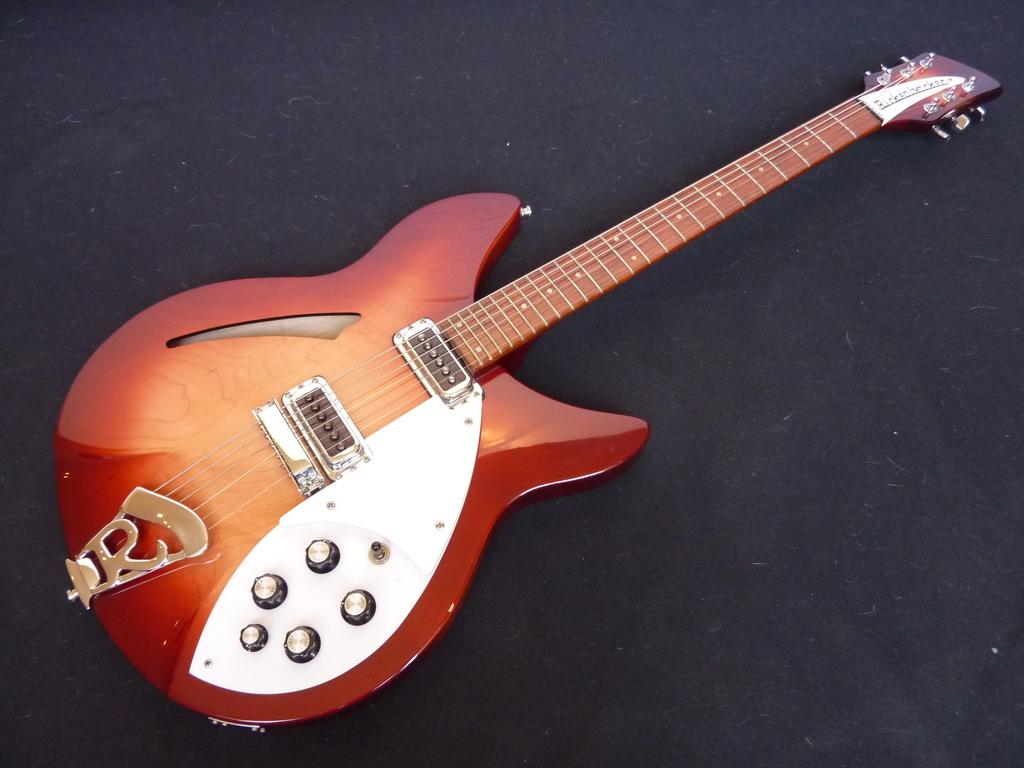What musical instrument is present in the image? There is a guitar in the image. What can be said about the appearance of the guitar? The guitar has multiple colors. How many strings are on the guitar? The guitar has six strings. Are there any additional features on the guitar? Yes, there are knobs on the guitar. What type of glove is being worn by the guitar in the image? There is no glove present in the image; it is a guitar, not a person wearing a glove. 